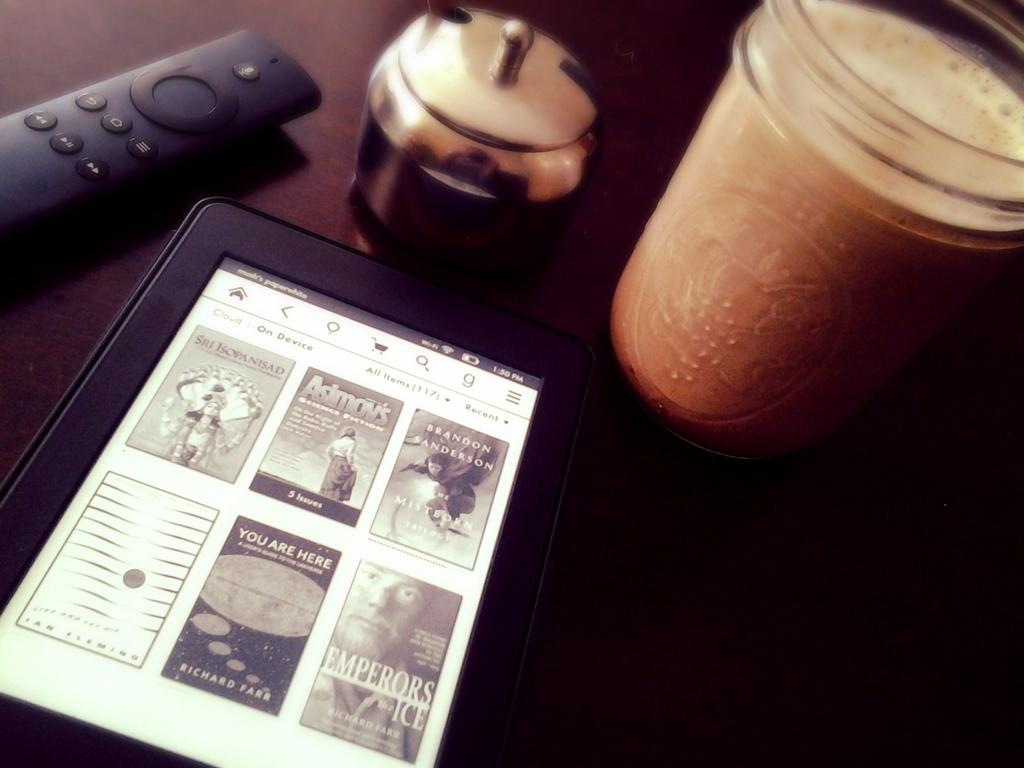<image>
Render a clear and concise summary of the photo. Tablet with Asimovs and other stories sits on the table next to a drink and remote. 